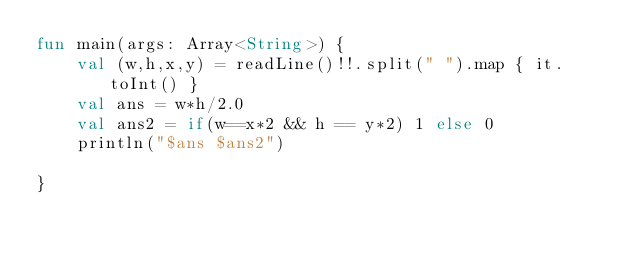Convert code to text. <code><loc_0><loc_0><loc_500><loc_500><_Kotlin_>fun main(args: Array<String>) {
    val (w,h,x,y) = readLine()!!.split(" ").map { it.toInt() }
    val ans = w*h/2.0
    val ans2 = if(w==x*2 && h == y*2) 1 else 0
    println("$ans $ans2")

}</code> 